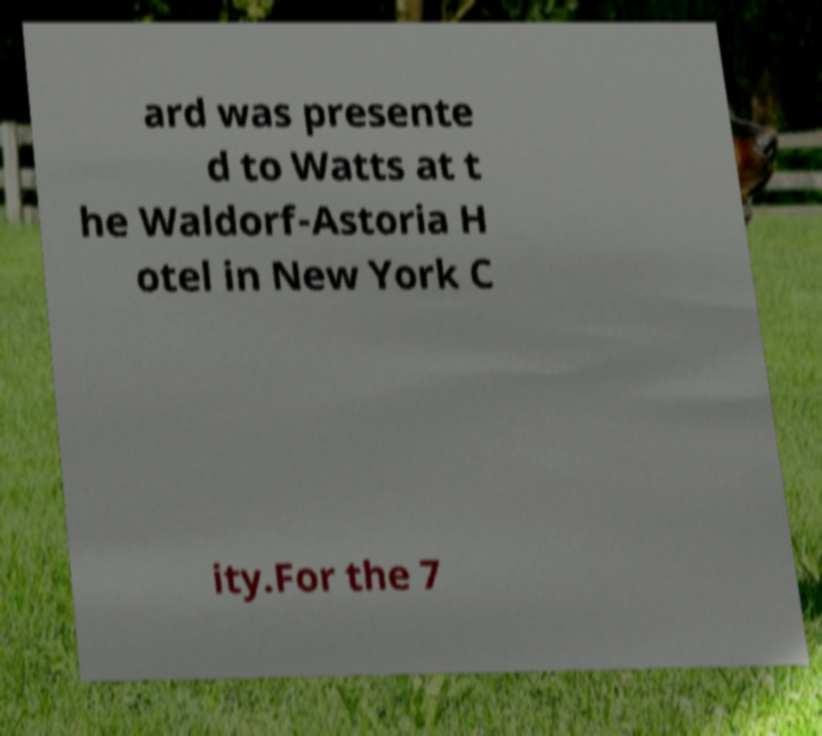There's text embedded in this image that I need extracted. Can you transcribe it verbatim? ard was presente d to Watts at t he Waldorf-Astoria H otel in New York C ity.For the 7 